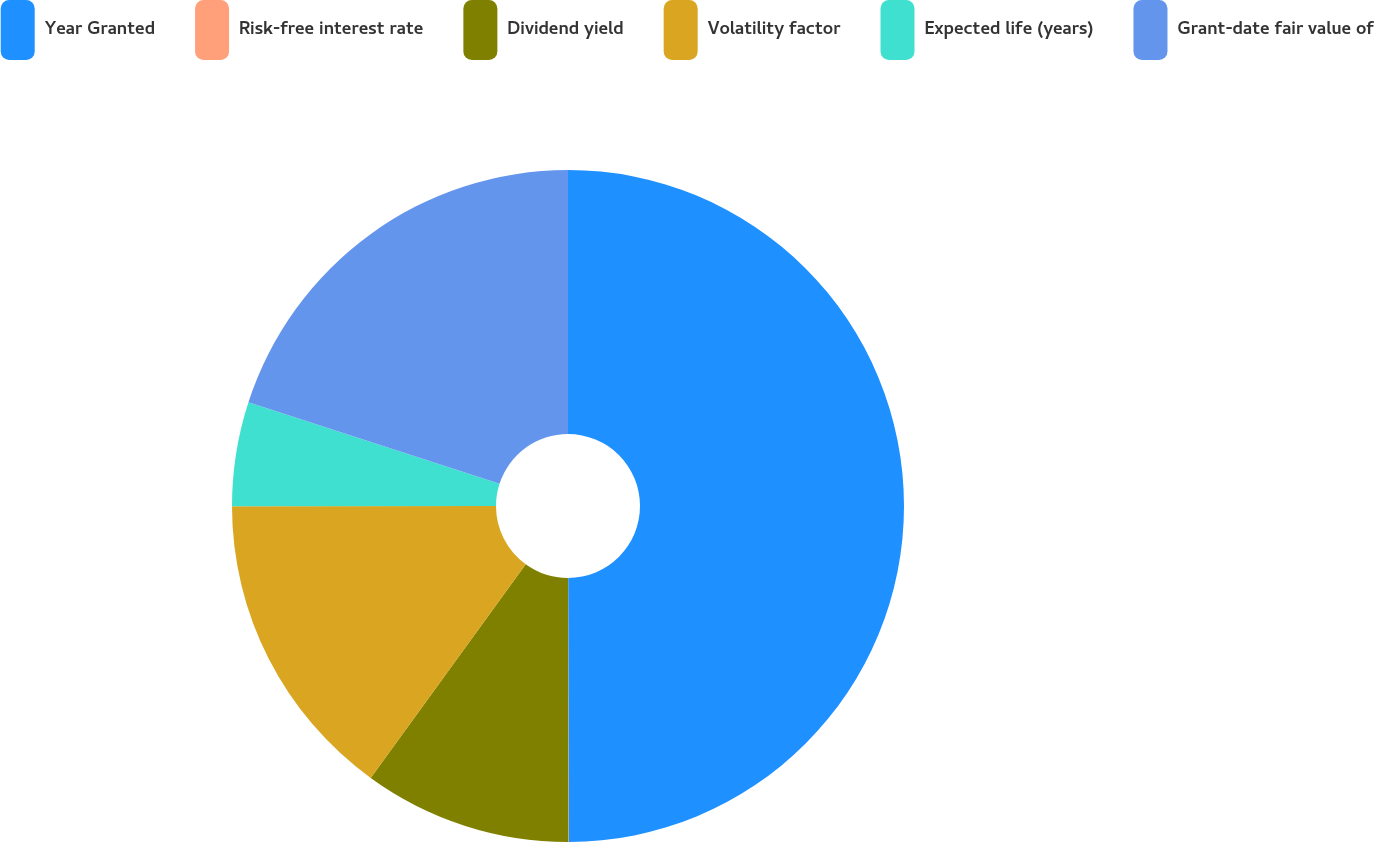<chart> <loc_0><loc_0><loc_500><loc_500><pie_chart><fcel>Year Granted<fcel>Risk-free interest rate<fcel>Dividend yield<fcel>Volatility factor<fcel>Expected life (years)<fcel>Grant-date fair value of<nl><fcel>49.96%<fcel>0.02%<fcel>10.01%<fcel>15.0%<fcel>5.01%<fcel>20.0%<nl></chart> 